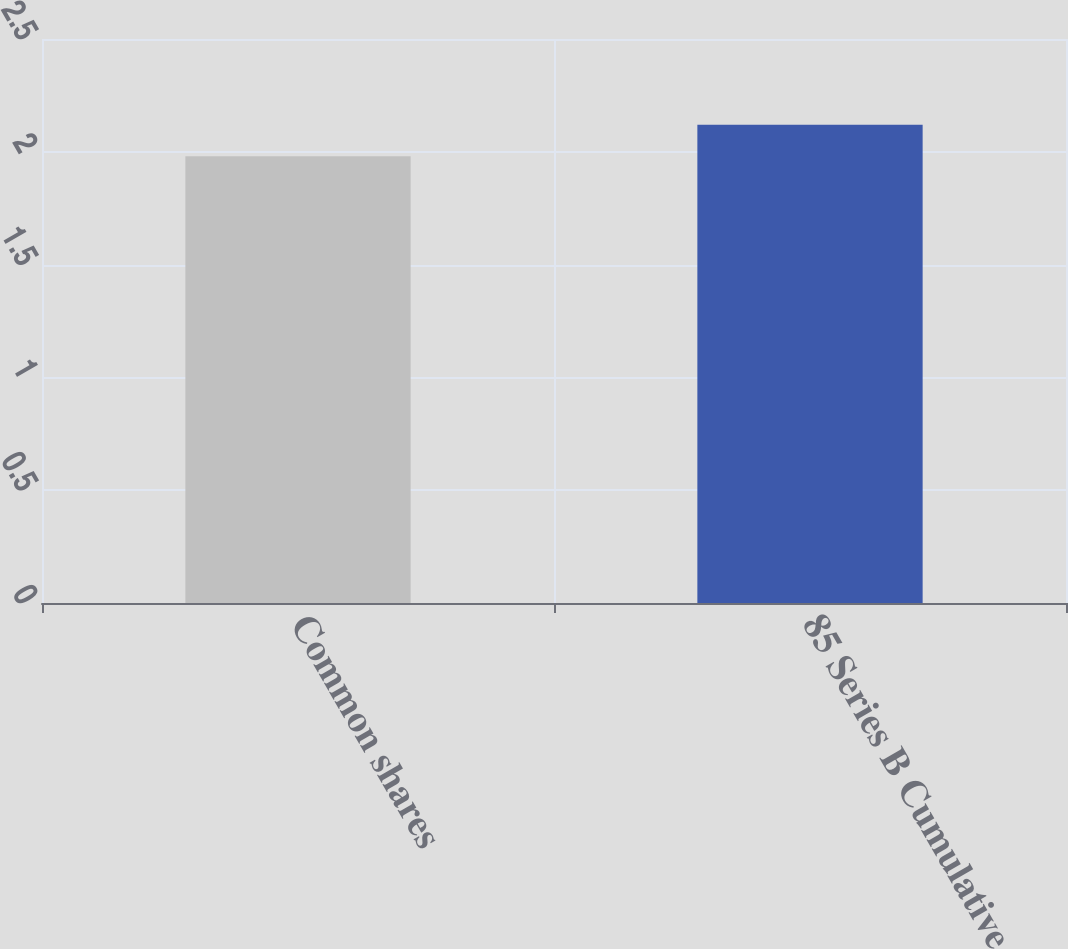<chart> <loc_0><loc_0><loc_500><loc_500><bar_chart><fcel>Common shares<fcel>85 Series B Cumulative<nl><fcel>1.98<fcel>2.12<nl></chart> 